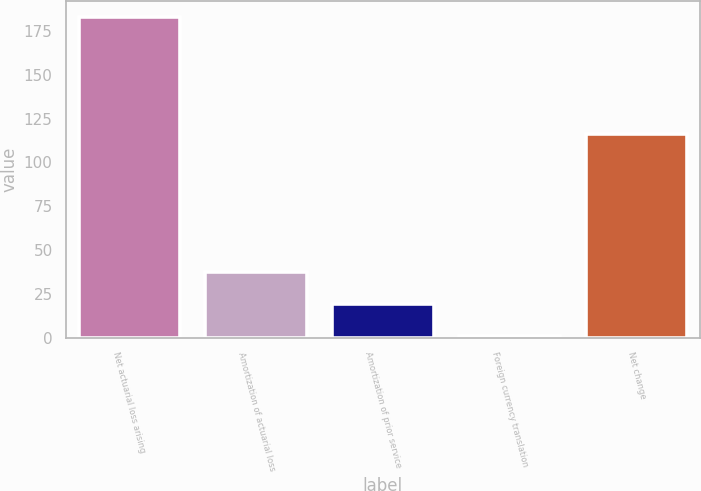Convert chart. <chart><loc_0><loc_0><loc_500><loc_500><bar_chart><fcel>Net actuarial loss arising<fcel>Amortization of actuarial loss<fcel>Amortization of prior service<fcel>Foreign currency translation<fcel>Net change<nl><fcel>183<fcel>37.4<fcel>19.2<fcel>1<fcel>116<nl></chart> 